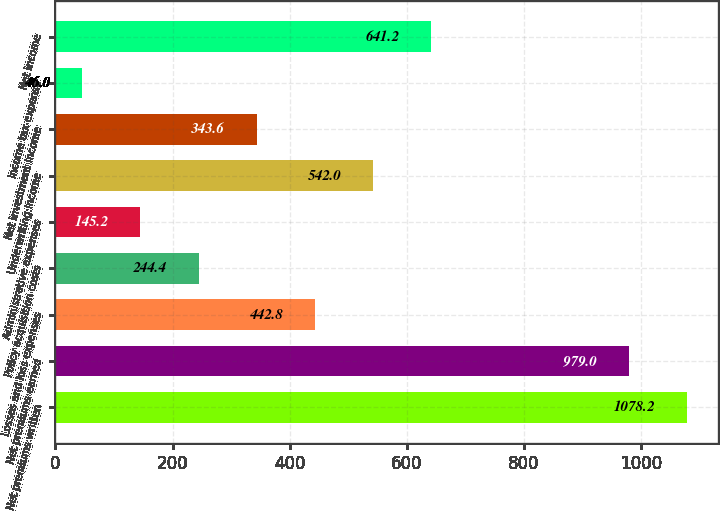<chart> <loc_0><loc_0><loc_500><loc_500><bar_chart><fcel>Net premiums written<fcel>Net premiums earned<fcel>Losses and loss expenses<fcel>Policy acquisition costs<fcel>Administrative expenses<fcel>Underwriting income<fcel>Net investment income<fcel>Income tax expense<fcel>Net income<nl><fcel>1078.2<fcel>979<fcel>442.8<fcel>244.4<fcel>145.2<fcel>542<fcel>343.6<fcel>46<fcel>641.2<nl></chart> 